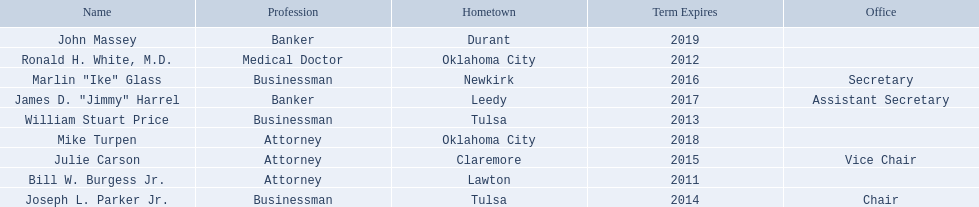What are all the names of oklahoma state regents for higher educations? Bill W. Burgess Jr., Ronald H. White, M.D., William Stuart Price, Joseph L. Parker Jr., Julie Carson, Marlin "Ike" Glass, James D. "Jimmy" Harrel, Mike Turpen, John Massey. Which ones are businessmen? William Stuart Price, Joseph L. Parker Jr., Marlin "Ike" Glass. Of those, who is from tulsa? William Stuart Price, Joseph L. Parker Jr. Whose term expires in 2014? Joseph L. Parker Jr. 